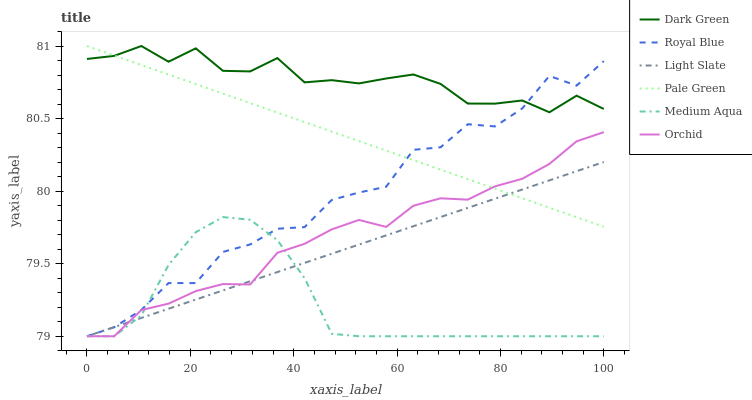Does Medium Aqua have the minimum area under the curve?
Answer yes or no. Yes. Does Dark Green have the maximum area under the curve?
Answer yes or no. Yes. Does Royal Blue have the minimum area under the curve?
Answer yes or no. No. Does Royal Blue have the maximum area under the curve?
Answer yes or no. No. Is Light Slate the smoothest?
Answer yes or no. Yes. Is Royal Blue the roughest?
Answer yes or no. Yes. Is Pale Green the smoothest?
Answer yes or no. No. Is Pale Green the roughest?
Answer yes or no. No. Does Light Slate have the lowest value?
Answer yes or no. Yes. Does Pale Green have the lowest value?
Answer yes or no. No. Does Dark Green have the highest value?
Answer yes or no. Yes. Does Royal Blue have the highest value?
Answer yes or no. No. Is Medium Aqua less than Pale Green?
Answer yes or no. Yes. Is Dark Green greater than Medium Aqua?
Answer yes or no. Yes. Does Medium Aqua intersect Orchid?
Answer yes or no. Yes. Is Medium Aqua less than Orchid?
Answer yes or no. No. Is Medium Aqua greater than Orchid?
Answer yes or no. No. Does Medium Aqua intersect Pale Green?
Answer yes or no. No. 